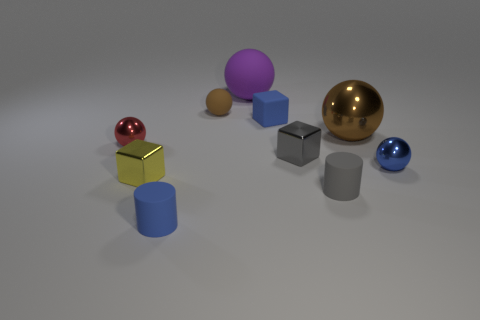Subtract all blue balls. How many balls are left? 4 Subtract all small blue balls. How many balls are left? 4 Subtract all cyan balls. Subtract all cyan cylinders. How many balls are left? 5 Subtract all cylinders. How many objects are left? 8 Subtract all small things. Subtract all purple metal objects. How many objects are left? 2 Add 4 blue spheres. How many blue spheres are left? 5 Add 5 purple objects. How many purple objects exist? 6 Subtract 0 red cylinders. How many objects are left? 10 